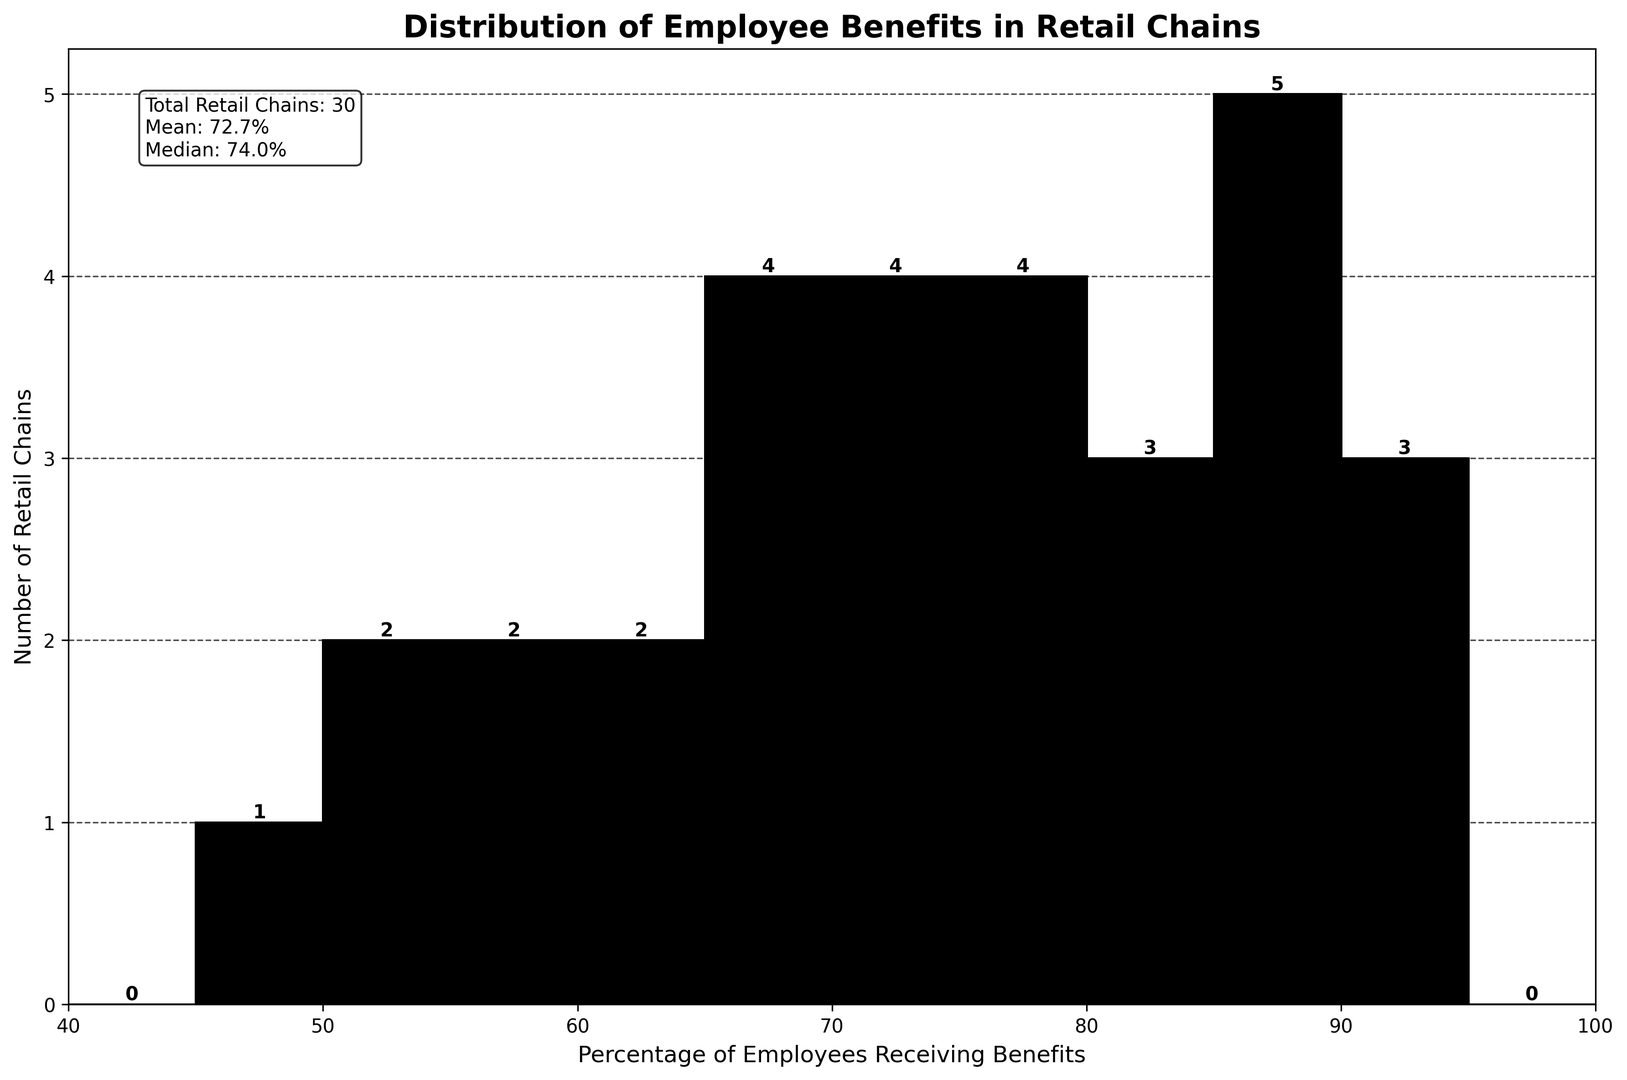What is the total number of retail chains represented in the histogram? The figure mentions the "Total Retail Chains" in a text box on the plot. Look for this value to find the total number.
Answer: 30 What is the mean percentage of employees receiving benefits? The text box on the plot provides the "Mean" value of the percentage of employees receiving benefits. Refer to this text for the answer.
Answer: 74.7% Which retail chain has the highest percentage of employees receiving benefits, and what is that percentage? The highest percentage is the maximum value on the horizontal axis. Locate the corresponding bar on the histogram. Trader Joe's and Wegmans both have the highest percentages, and their individual percentages can be cross-checked with data.
Answer: Trader Joe's and Wegmans, 90% Which retail chain has the lowest percentage of employees receiving benefits, and what is that percentage? The lowest percentage is the minimum value on the horizontal axis. Locate the corresponding bar on the histogram. Check the list for the chain with 45%.
Answer: Subway, 45% How many retail chains offer benefits to 70% or fewer employees? Count the bins on the histogram that are ≤ 70%, then sum the heights (numbers of retail chains) of these bars. Bins ≤ 70% correspond to 45, 50, 55, 60, 65, and 70 on the x-axis.
Answer: 11 What is the median percentage of employees receiving benefits? The text box on the plot provides the "Median" value of the percentage of employees receiving benefits. Refer to this text for the answer.
Answer: 75% What range of percentages contains the highest number of retail chains? Identify the tallest bar on the histogram. Check the range of the bin where this bar is located. The highest number of retail chains corresponds to the tallest bar.
Answer: 70-75% Compare the number of retail chains offering benefits to at least 80% of their employees with those offering benefits to less than 60% of their employees. Which is higher? Calculate the number of chains for ≥ 80% from bins corresponding to 80, 85, 90, 95. Calculate the number of chains for < 60% from bins corresponding to 45, 50, 55. Compare the totals.
Answer: ≥ 80% is higher Visualize the bins containing the lowest and highest percentages of chains and describe their heights. Identify the bins with the maximum and minimum frequencies. Maximum corresponds to the highest bar, and minimum to the lowest non-zero bar in the histogram.
Answer: Bins 70-75% (highest) and 95% (lowest) Is the distribution of percentages more skewed towards higher or lower values? Observe the overall shape of the histogram. If more values are clustered to the left (lower), it's skewed lower. If to the right (higher), it's skewed higher. Summarize the distribution shape for the conclusion.
Answer: Skewed towards lower values, but with notable values at higher percentages 